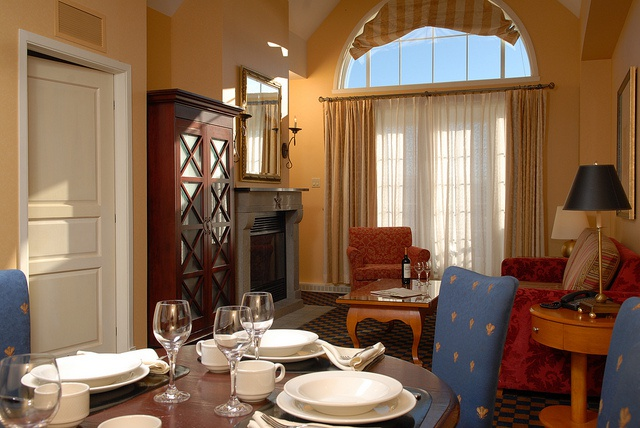Describe the objects in this image and their specific colors. I can see couch in olive, maroon, black, and brown tones, chair in olive, maroon, black, and brown tones, chair in olive, gray, darkblue, navy, and black tones, dining table in olive, gray, brown, and maroon tones, and chair in olive, black, gray, and maroon tones in this image. 